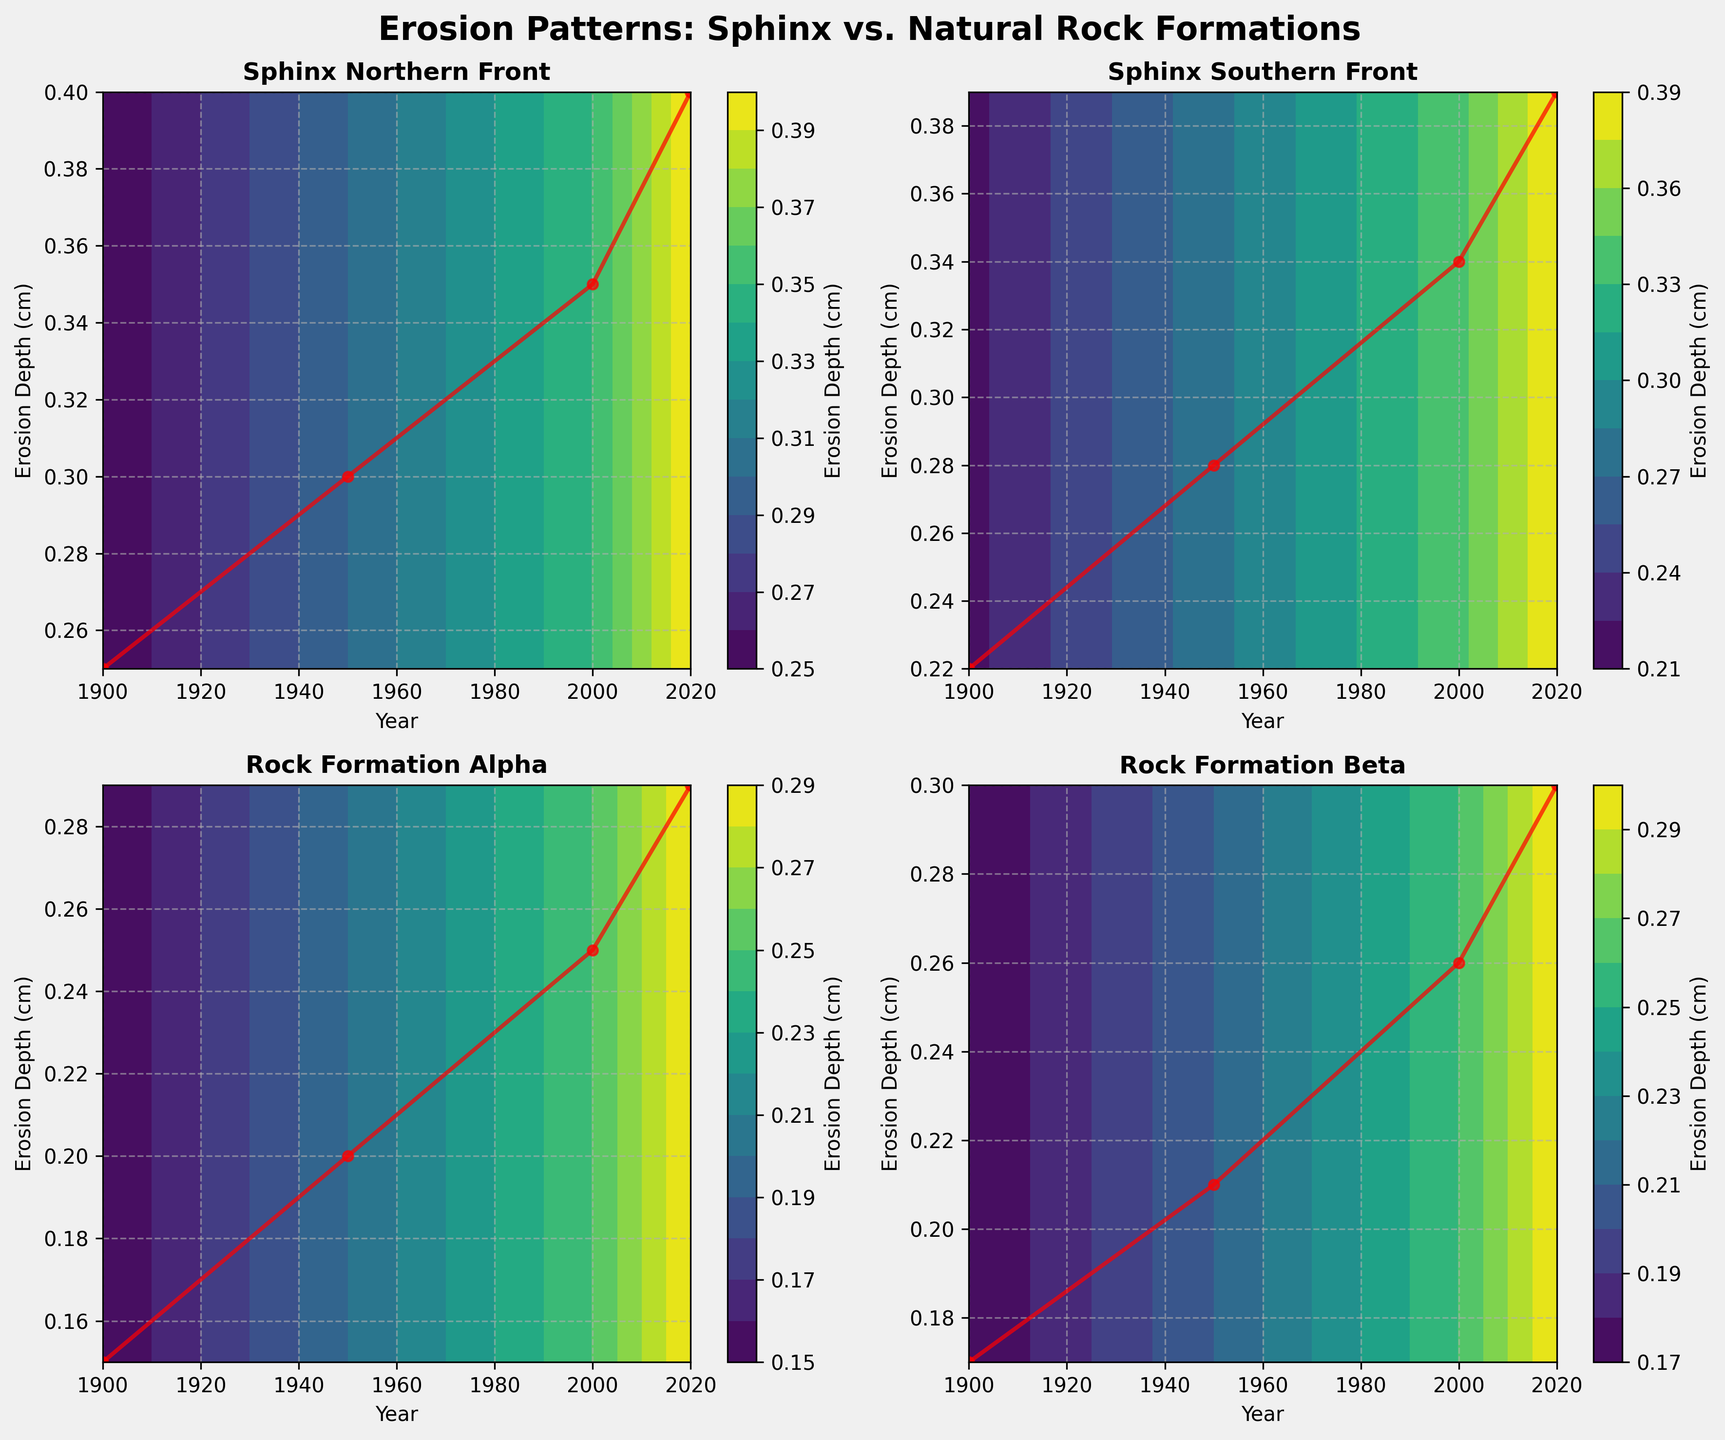How many subplots are shown in the figure? The figure has been divided into a 2x2 grid, which creates a total of 4 subplots. You can see each subplot with individual titles that correspond to different locations.
Answer: 4 Which subplot represents the "Rock Formation Alpha"? Each subplot's title corresponds to a different location. The subplot with the title "Rock Formation Alpha" is the one you are looking for.
Answer: Bottom left In which year did the "Sphinx Northern Front" have the highest recorded erosion depth? The "Sphinx Northern Front" subplot shows the erosion depth at different years. The highest point on the y-axis corresponds to the year 2020.
Answer: 2020 Compare the erosion depth of "Sphinx Southern Front" and "Rock Formation Beta" in 1900. Which one had greater erosion depth? To compare, look at the points for the year 1900 in both subplots. The "Sphinx Southern Front" has an erosion depth of 0.22 cm, while the "Rock Formation Beta" has 0.17 cm.
Answer: Sphinx Southern Front What color gradient is used to represent the erosion depth in the contours? The color gradient representing the erosion depth is given by the color bar, showing a range from light green to dark purple.
Answer: light green to dark purple How does the erosion pattern of "Sphinx Northern Front" compare to "Rock Formation Alpha" between 1950 and 2000? Look at the erosion depths at the years 1950 and 2000 in both subplots. "Sphinx Northern Front" increases from 0.30 cm to 0.35 cm, while "Rock Formation Alpha" increases from 0.20 cm to 0.25 cm. The erosion increment for Sphinx Northern Front is greater.
Answer: Sphinx Northern Front has a higher increase What does the x-axis represent in all the subplots? In all the subplots, the x-axis indicates the years over which erosion measurements were taken.
Answer: Years What is the average erosion depth for "Rock Formation Beta" between 1900 and 2020? For "Rock Formation Beta", the erosion depths are given as 0.17 cm, 0.21 cm, 0.26 cm, and 0.30 cm for the years 1900, 1950, 2000, and 2020 respectively. To find the average: (0.17 + 0.21 + 0.26 + 0.30) / 4 = 0.235 cm.
Answer: 0.235 cm Is there any subplot where the erosion depth decreases over time? By examining the trajectories in all subplots, none show a decrease in erosion depth over time; all erosion depths increase as years progress.
Answer: No 